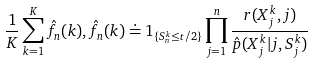<formula> <loc_0><loc_0><loc_500><loc_500>\frac { 1 } { K } \sum _ { k = 1 } ^ { K } \hat { f } _ { n } ( k ) , \hat { f } _ { n } ( k ) \doteq 1 _ { \{ S ^ { k } _ { n } \leq t / 2 \} } \prod _ { j = 1 } ^ { n } \frac { r ( X ^ { k } _ { j } , j ) } { \hat { p } ( X ^ { k } _ { j } | j , S ^ { k } _ { j } ) }</formula> 